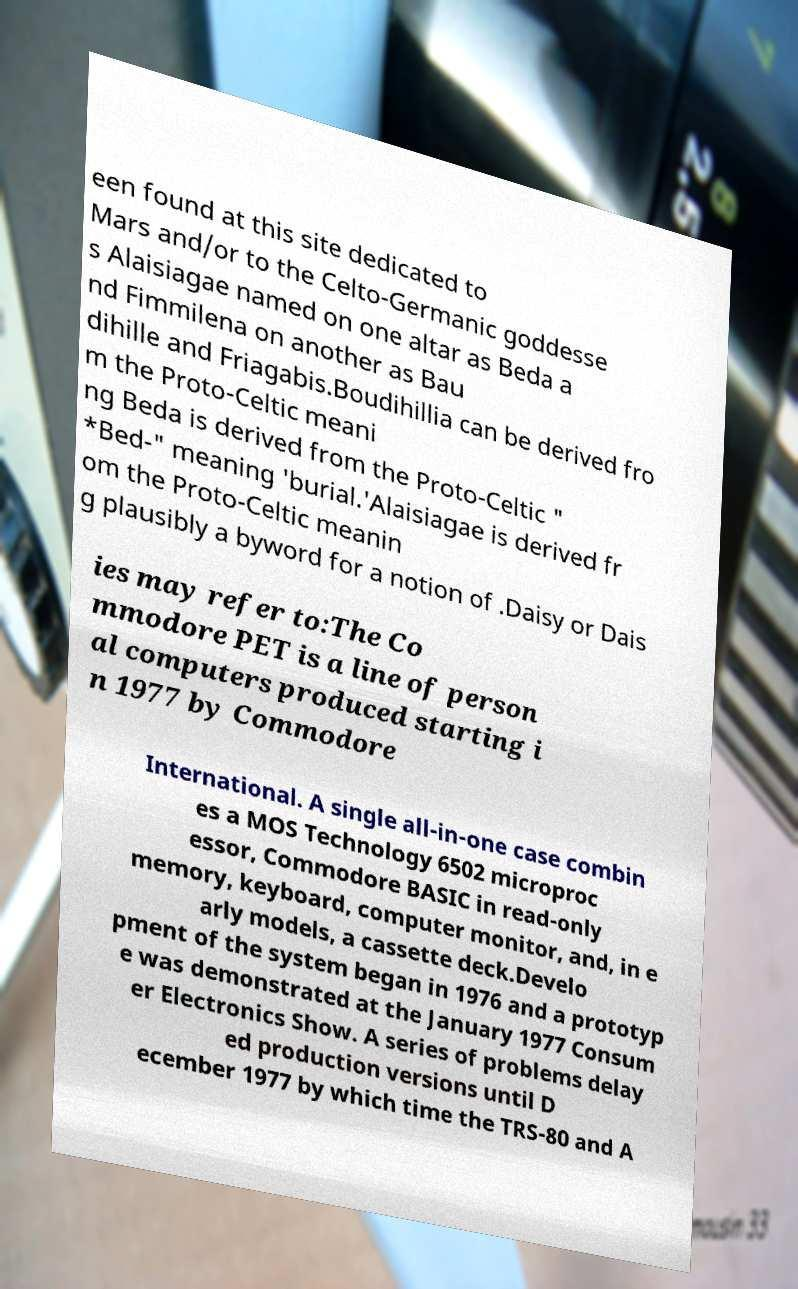Could you extract and type out the text from this image? een found at this site dedicated to Mars and/or to the Celto-Germanic goddesse s Alaisiagae named on one altar as Beda a nd Fimmilena on another as Bau dihille and Friagabis.Boudihillia can be derived fro m the Proto-Celtic meani ng Beda is derived from the Proto-Celtic " *Bed-" meaning 'burial.'Alaisiagae is derived fr om the Proto-Celtic meanin g plausibly a byword for a notion of .Daisy or Dais ies may refer to:The Co mmodore PET is a line of person al computers produced starting i n 1977 by Commodore International. A single all-in-one case combin es a MOS Technology 6502 microproc essor, Commodore BASIC in read-only memory, keyboard, computer monitor, and, in e arly models, a cassette deck.Develo pment of the system began in 1976 and a prototyp e was demonstrated at the January 1977 Consum er Electronics Show. A series of problems delay ed production versions until D ecember 1977 by which time the TRS-80 and A 